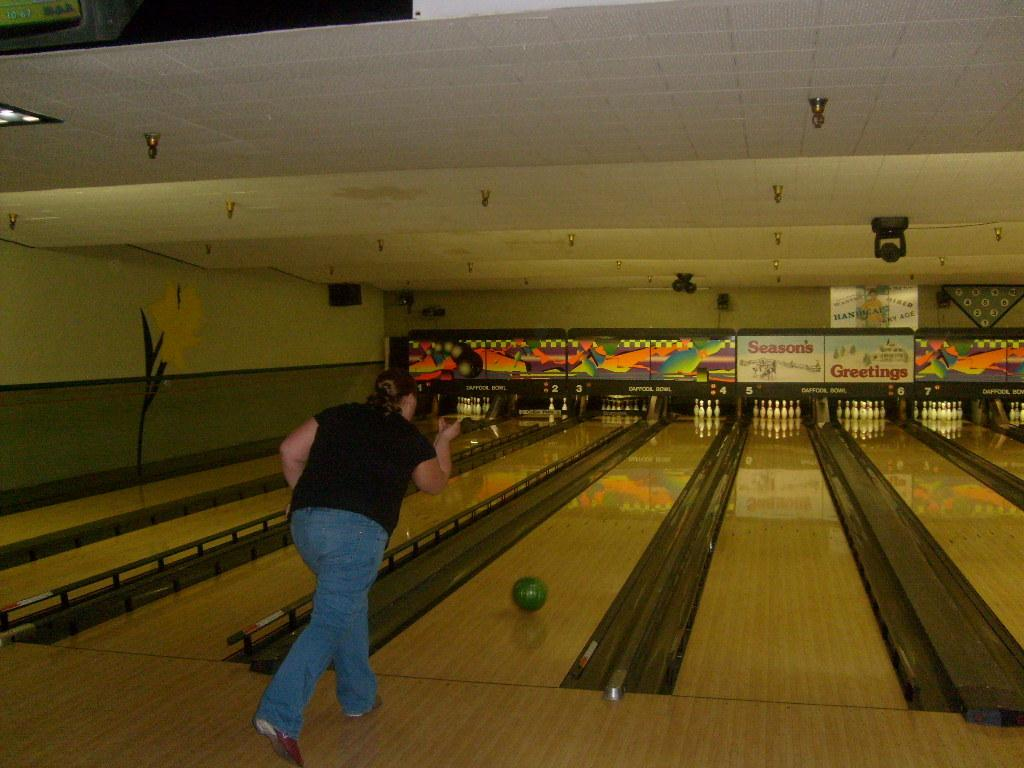What is the person in the image doing? The person is doing bowling in the image. What type of lighting is present in the image? There are electric lights visible in the image. What else can be seen in the image besides the person bowling? There are advertisement boards in the image. Where is the gate mentioned in the image? There is no gate mentioned or visible in the image. What type of rings are being exchanged during the meeting in the image? There is no meeting or exchange of rings present in the image. 